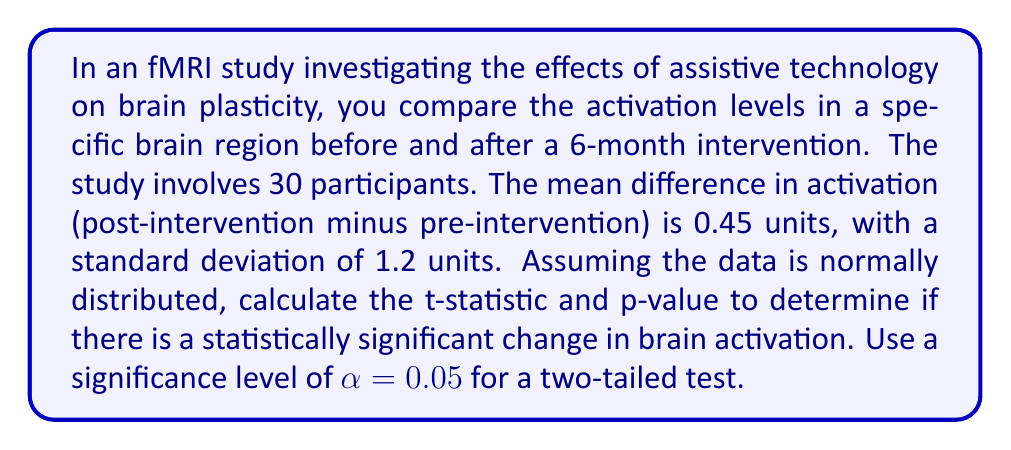Can you answer this question? To determine if there is a statistically significant change in brain activation, we need to perform a paired t-test. We'll follow these steps:

1. Calculate the t-statistic:
   The formula for the t-statistic in a paired t-test is:
   
   $$ t = \frac{\bar{d}}{s_d / \sqrt{n}} $$
   
   Where:
   $\bar{d}$ = mean difference = 0.45
   $s_d$ = standard deviation of differences = 1.2
   $n$ = sample size = 30

   Substituting these values:
   
   $$ t = \frac{0.45}{1.2 / \sqrt{30}} = \frac{0.45}{0.219} = 2.055 $$

2. Calculate the degrees of freedom:
   $df = n - 1 = 30 - 1 = 29$

3. Determine the critical t-value:
   For a two-tailed test with α = 0.05 and df = 29, the critical t-value is approximately ±2.045 (from t-distribution tables).

4. Calculate the p-value:
   Using a t-distribution calculator or table, we find that the p-value for t = 2.055 with 29 degrees of freedom is approximately 0.0489.

5. Interpret the results:
   Since the calculated t-statistic (2.055) is greater than the critical t-value (2.045) and the p-value (0.0489) is less than the significance level (0.05), we can conclude that there is a statistically significant change in brain activation.
Answer: t-statistic = 2.055, p-value = 0.0489. The change in brain activation is statistically significant at α = 0.05. 